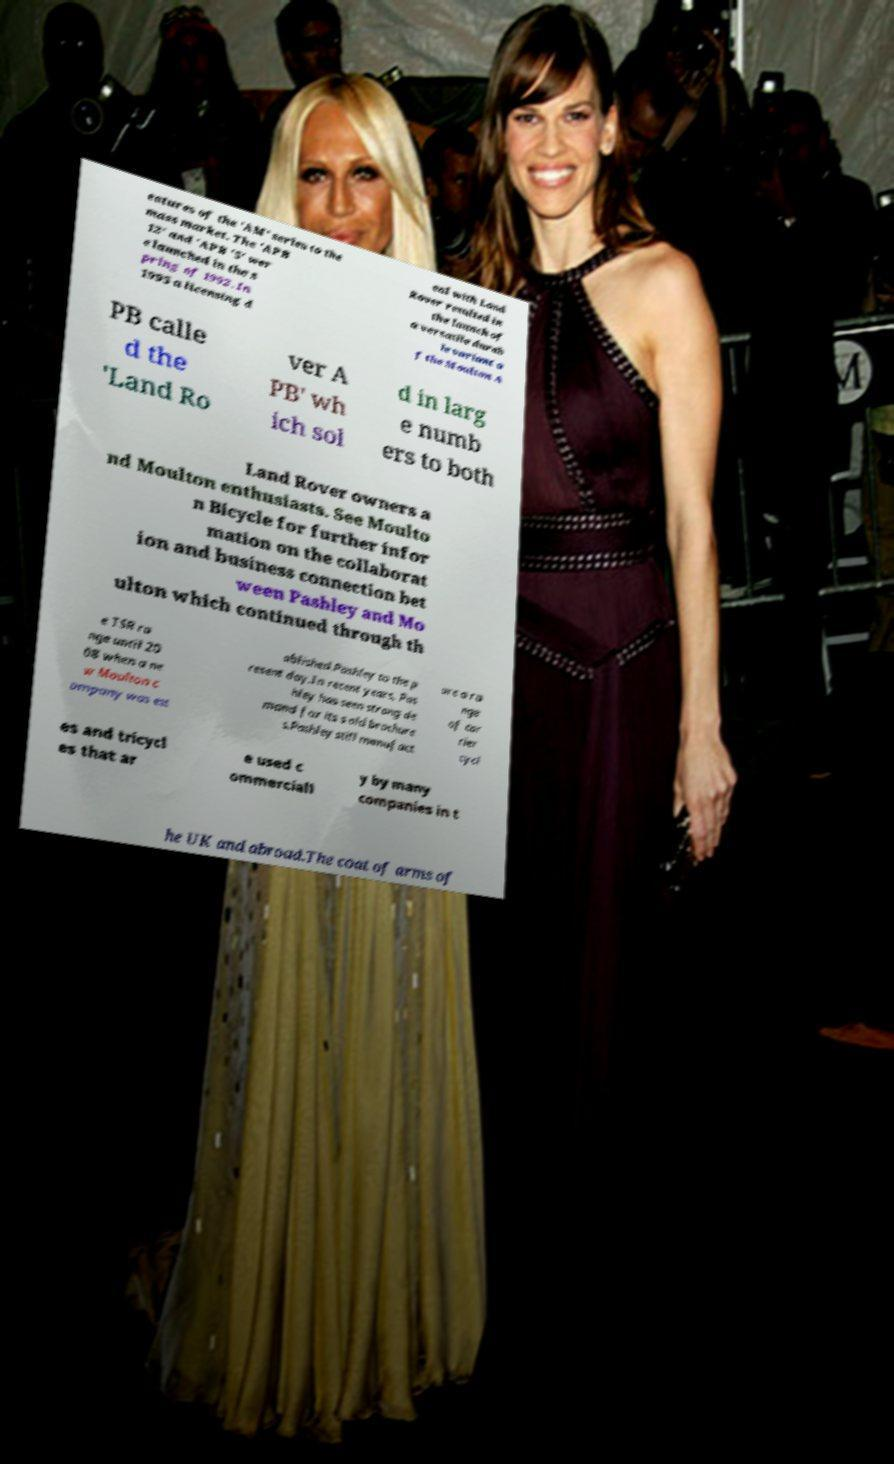Could you assist in decoding the text presented in this image and type it out clearly? eatures of the 'AM' series to the mass market. The 'APB 12' and 'APB '5' wer e launched in the s pring of 1992. In 1995 a licensing d eal with Land Rover resulted in the launch of a versatile durab le variant o f the Moulton A PB calle d the 'Land Ro ver A PB' wh ich sol d in larg e numb ers to both Land Rover owners a nd Moulton enthusiasts. See Moulto n Bicycle for further infor mation on the collaborat ion and business connection bet ween Pashley and Mo ulton which continued through th e TSR ra nge until 20 08 when a ne w Moulton c ompany was est ablished.Pashley to the p resent day.In recent years, Pas hley has seen strong de mand for its s old brochure s.Pashley still manufact ure a ra nge of car rier cycl es and tricycl es that ar e used c ommerciall y by many companies in t he UK and abroad.The coat of arms of 